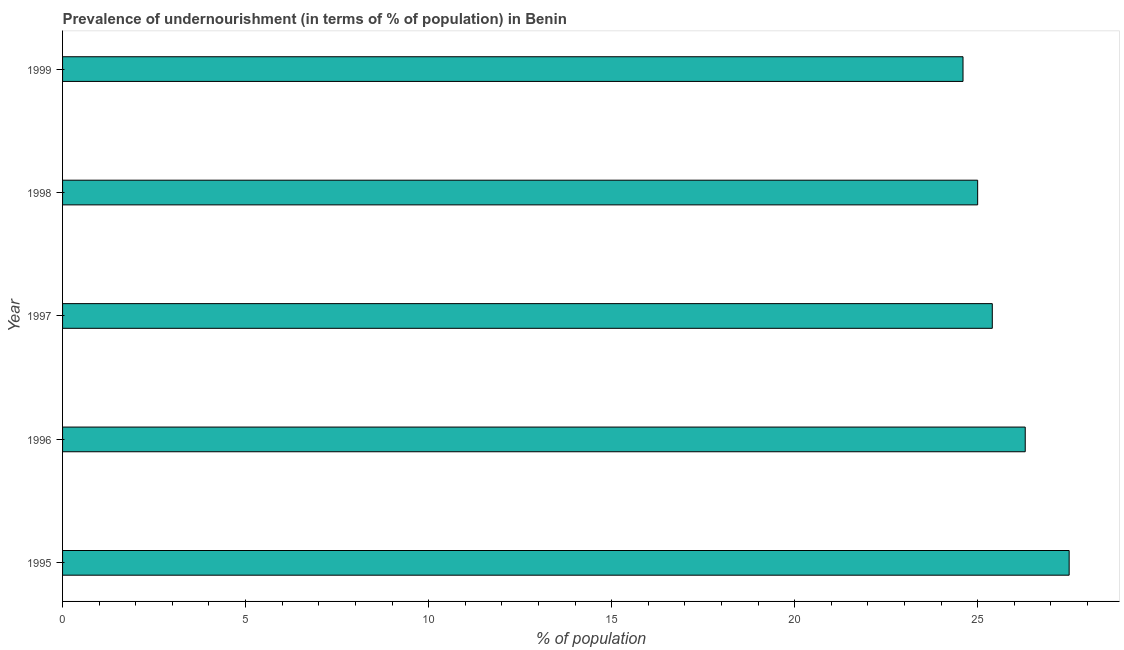Does the graph contain any zero values?
Provide a short and direct response. No. Does the graph contain grids?
Ensure brevity in your answer.  No. What is the title of the graph?
Offer a terse response. Prevalence of undernourishment (in terms of % of population) in Benin. What is the label or title of the X-axis?
Your answer should be compact. % of population. What is the percentage of undernourished population in 1999?
Offer a very short reply. 24.6. Across all years, what is the maximum percentage of undernourished population?
Provide a short and direct response. 27.5. Across all years, what is the minimum percentage of undernourished population?
Make the answer very short. 24.6. In which year was the percentage of undernourished population maximum?
Provide a succinct answer. 1995. In which year was the percentage of undernourished population minimum?
Give a very brief answer. 1999. What is the sum of the percentage of undernourished population?
Make the answer very short. 128.8. What is the average percentage of undernourished population per year?
Offer a very short reply. 25.76. What is the median percentage of undernourished population?
Provide a short and direct response. 25.4. In how many years, is the percentage of undernourished population greater than 13 %?
Make the answer very short. 5. What is the ratio of the percentage of undernourished population in 1996 to that in 1999?
Give a very brief answer. 1.07. What is the difference between the highest and the second highest percentage of undernourished population?
Provide a succinct answer. 1.2. Is the sum of the percentage of undernourished population in 1996 and 1998 greater than the maximum percentage of undernourished population across all years?
Provide a short and direct response. Yes. In how many years, is the percentage of undernourished population greater than the average percentage of undernourished population taken over all years?
Your answer should be compact. 2. Are all the bars in the graph horizontal?
Provide a short and direct response. Yes. What is the difference between two consecutive major ticks on the X-axis?
Provide a short and direct response. 5. What is the % of population in 1996?
Make the answer very short. 26.3. What is the % of population of 1997?
Ensure brevity in your answer.  25.4. What is the % of population of 1998?
Provide a succinct answer. 25. What is the % of population in 1999?
Your answer should be very brief. 24.6. What is the difference between the % of population in 1995 and 1996?
Provide a short and direct response. 1.2. What is the difference between the % of population in 1995 and 1997?
Give a very brief answer. 2.1. What is the difference between the % of population in 1996 and 1997?
Your response must be concise. 0.9. What is the difference between the % of population in 1996 and 1999?
Offer a very short reply. 1.7. What is the difference between the % of population in 1998 and 1999?
Ensure brevity in your answer.  0.4. What is the ratio of the % of population in 1995 to that in 1996?
Offer a very short reply. 1.05. What is the ratio of the % of population in 1995 to that in 1997?
Your response must be concise. 1.08. What is the ratio of the % of population in 1995 to that in 1998?
Your response must be concise. 1.1. What is the ratio of the % of population in 1995 to that in 1999?
Give a very brief answer. 1.12. What is the ratio of the % of population in 1996 to that in 1997?
Your response must be concise. 1.03. What is the ratio of the % of population in 1996 to that in 1998?
Offer a very short reply. 1.05. What is the ratio of the % of population in 1996 to that in 1999?
Offer a very short reply. 1.07. What is the ratio of the % of population in 1997 to that in 1999?
Give a very brief answer. 1.03. 